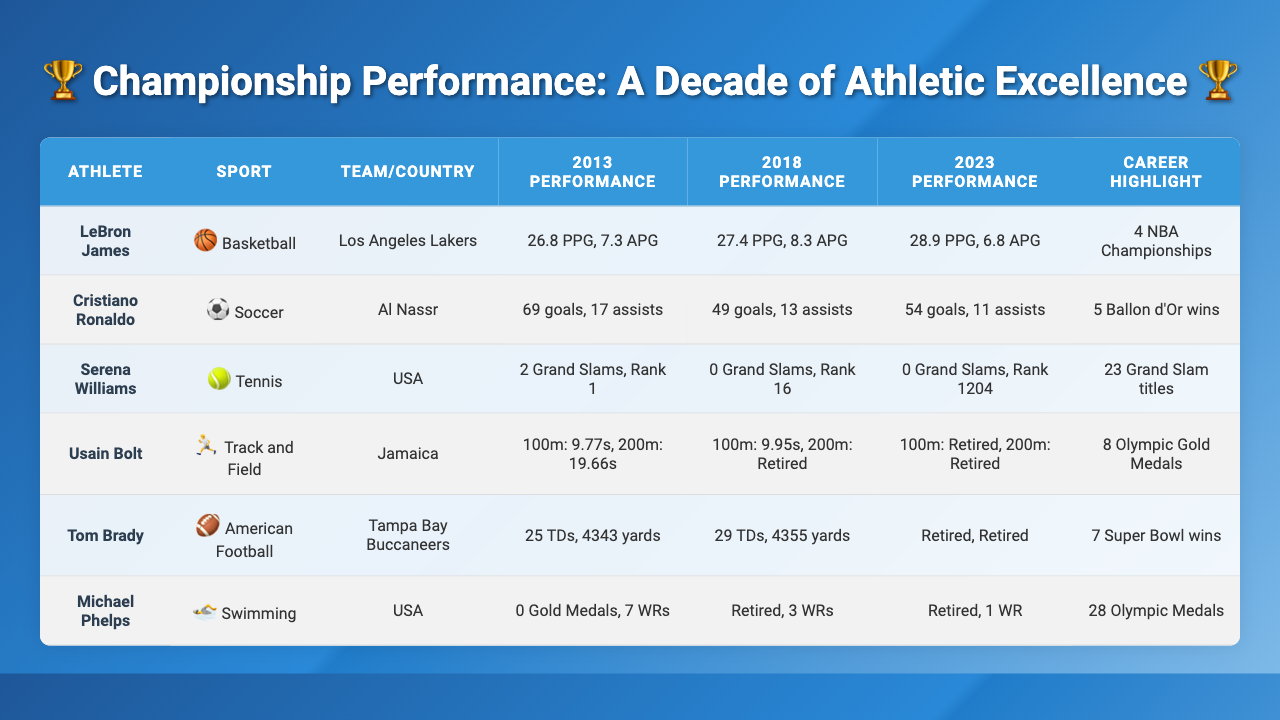What were LeBron James' points per game in 2023? According to the table, LeBron James' points per game in 2023 are listed as 28.9.
Answer: 28.9 How many Ballon d'Or wins does Cristiano Ronaldo have? The table shows that Cristiano Ronaldo has 5 Ballon d'Or wins listed under career highlights.
Answer: 5 Did Serena Williams win any Grand Slams in 2023? The table indicates that Serena Williams had 0 Grand Slams in 2023, confirming she did not win any.
Answer: No Who had the highest average points per game in 2018? From the data, LeBron James had 27.4 points per game in 2018, while Cristiano Ronaldo's goals do not directly compare. Therefore, he had the highest performance in this category.
Answer: LeBron James What was Usain Bolt's 100m best time in 2013? The table lists Usain Bolt's best time for the 100m in 2013 as 9.77 seconds.
Answer: 9.77 seconds How many Olympic Gold Medals does Usain Bolt have compared to Michael Phelps? Usain Bolt has 8 Olympic Gold Medals, while Michael Phelps has 0 current gold medals (as he is retired), making Usain Bolt the holder of more gold medals.
Answer: Usain Bolt has more medals In which year did Tom Brady have the highest number of touchdown passes? Looking at the table, Tom Brady had 29 touchdown passes in 2018, which is the highest recorded compared to other years.
Answer: 2018 What was the trend in LeBron James' assists per game from 2013 to 2023? LeBron James had 7.3 assists per game in 2013, increased to 8.3 in 2018, and then decreased to 6.8 in 2023, showing a fluctuation in performance.
Answer: Decreased Which athlete had the most significant drop in world ranking from 2013 to 2023? Serena Williams dropped from world ranking 1 in 2013 to 1204 in 2023, which is a significant drop compared to any other athlete.
Answer: Serena Williams What was the total increase in goals for Cristiano Ronaldo from 2013 to 2023? Cristiano Ronaldo had 69 goals in 2013 and 54 goals in 2023, which is a decrease of 15 goals over the decade.
Answer: Decrease of 15 goals If you average the best times for Usain Bolt in the 100m over the years he competed, what would that average be excluding retirement years? Taking only the 2013 (9.77 seconds) and 2018 (9.95 seconds) times, the average is (9.77 + 9.95) / 2 = 9.86 seconds.
Answer: 9.86 seconds 